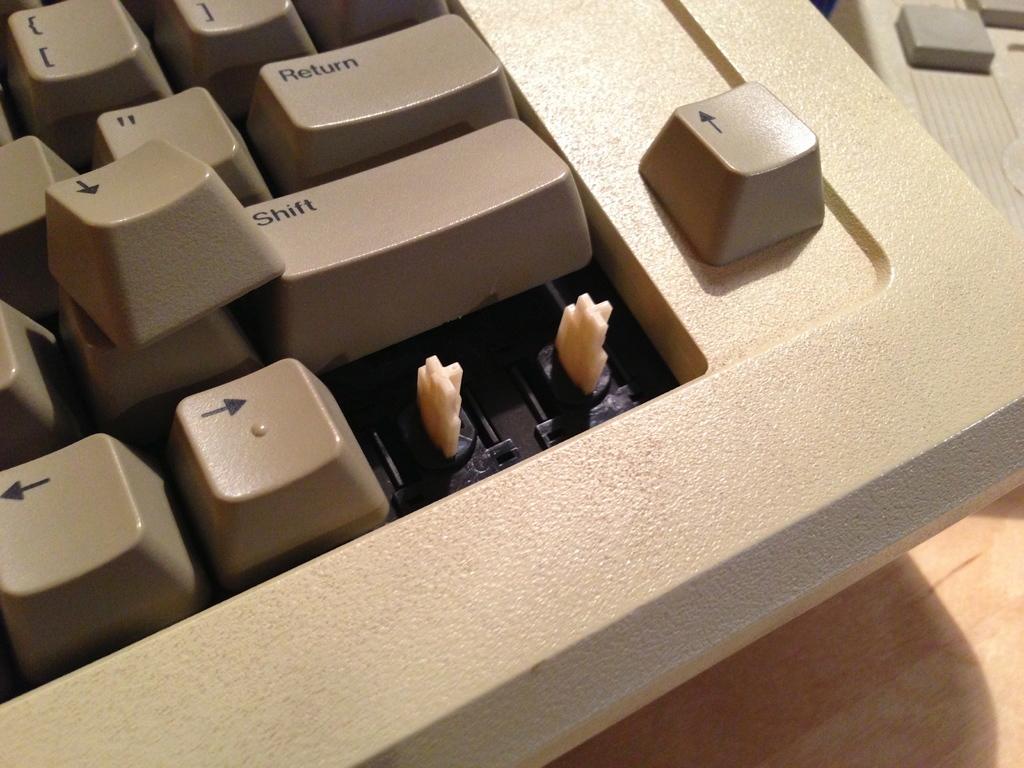What is printed on the two remaining keys with words on them?
Your response must be concise. Return shift. This is a keyboard?
Your answer should be very brief. Yes. 